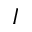Convert formula to latex. <formula><loc_0><loc_0><loc_500><loc_500>I</formula> 